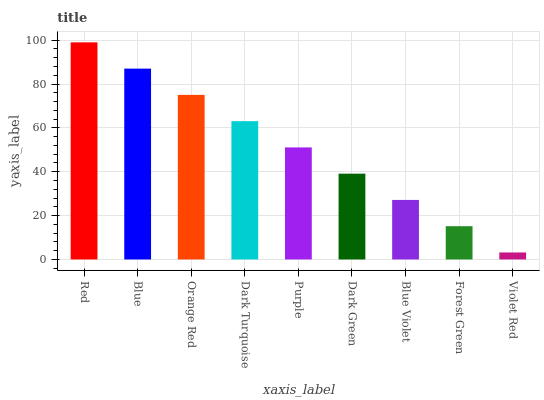Is Violet Red the minimum?
Answer yes or no. Yes. Is Red the maximum?
Answer yes or no. Yes. Is Blue the minimum?
Answer yes or no. No. Is Blue the maximum?
Answer yes or no. No. Is Red greater than Blue?
Answer yes or no. Yes. Is Blue less than Red?
Answer yes or no. Yes. Is Blue greater than Red?
Answer yes or no. No. Is Red less than Blue?
Answer yes or no. No. Is Purple the high median?
Answer yes or no. Yes. Is Purple the low median?
Answer yes or no. Yes. Is Blue the high median?
Answer yes or no. No. Is Dark Turquoise the low median?
Answer yes or no. No. 